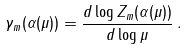<formula> <loc_0><loc_0><loc_500><loc_500>\gamma _ { m } ( \alpha ( \mu ) ) = \frac { d \log Z _ { m } ( \alpha ( \mu ) ) } { d \log \mu } \, .</formula> 